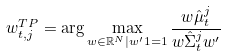<formula> <loc_0><loc_0><loc_500><loc_500>w _ { t , j } ^ { T P } = \arg \max _ { w \in \mathbb { R } ^ { N } | w ^ { \prime } 1 = 1 } { \frac { w \hat { \mu } _ { t } ^ { j } } { w \hat { \Sigma } _ { t } ^ { j } w ^ { \prime } } }</formula> 